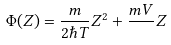<formula> <loc_0><loc_0><loc_500><loc_500>\Phi ( Z ) = \frac { m } { 2 \hbar { T } } Z ^ { 2 } + \frac { m V } { } Z</formula> 